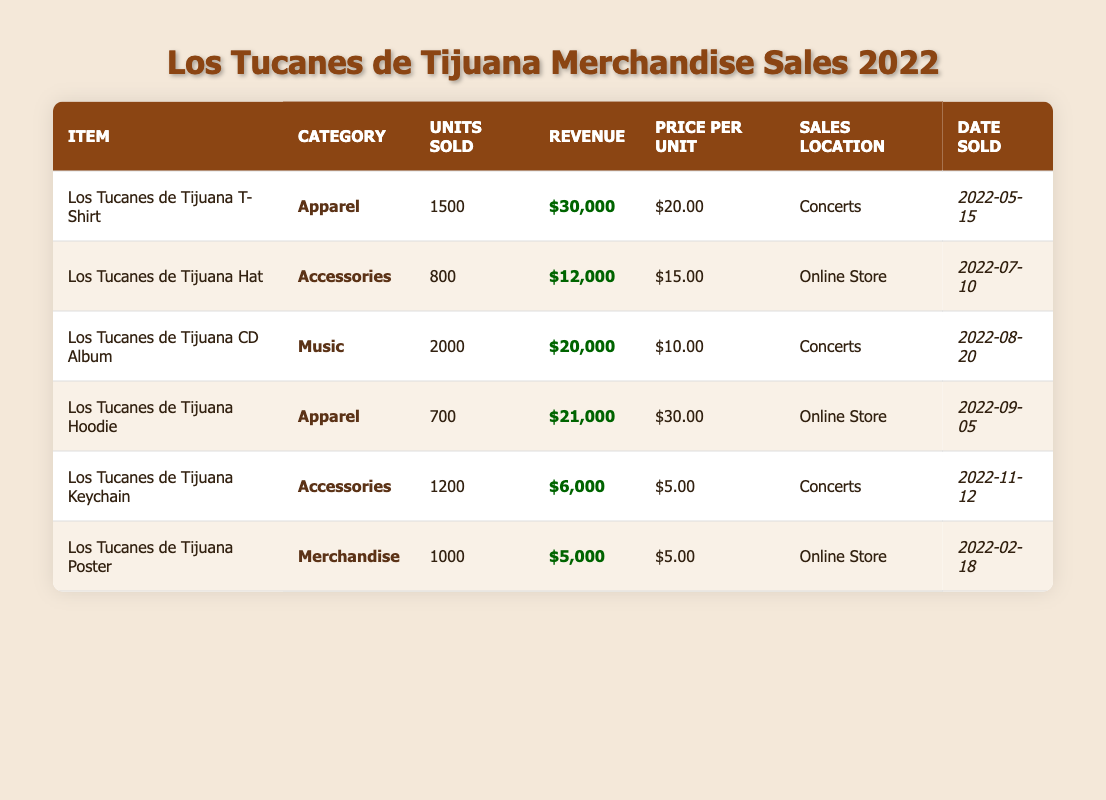What item sold the most units? The item that sold the most units can be found by looking at the "Units Sold" column. Comparing the values, the "Los Tucanes de Tijuana CD Album" has the highest units sold at 2000.
Answer: Los Tucanes de Tijuana CD Album What was the total revenue from merchandise sales? To find the total revenue, we add the revenue for each item: $30,000 + $12,000 + $20,000 + $21,000 + $6,000 + $5,000 = $94,000.
Answer: $94,000 How much revenue did the accessories category generate? The accessories category includes the "Los Tucanes de Tijuana Hat" ($12,000) and "Los Tucanes de Tijuana Keychain" ($6,000). Adding these together gives $12,000 + $6,000 = $18,000.
Answer: $18,000 Did the Los Tucanes de Tijuana generate more revenue from online sales or concert sales? We compare the revenue from online sales ($12,000 from the hat, $21,000 from the hoodie, and $5,000 from the poster) totaling $38,000 to concert sales ($30,000 from the t-shirt, $20,000 from the CD album, and $6,000 from the keychain) totaling $56,000. Since $56,000 is greater than $38,000, concert sales generated more revenue.
Answer: Yes What is the average price per unit for apparel? The apparel items are the "T-Shirt" ($20.00) and "Hoodie" ($30.00). To find the average, we sum the prices ($20.00 + $30.00 = $50.00) and divide by the number of items (2): $50.00 / 2 = $25.00.
Answer: $25.00 Which item had the highest price per unit and what was it? We can look at the "Price per Unit" column to find the item with the highest value. The "Los Tucanes de Tijuana Hoodie" is listed at $30.00, which is higher than the prices of other items.
Answer: Los Tucanes de Tijuana Hoodie, $30.00 What was the sales location for the least sold item? The least sold item is the "Los Tucanes de Tijuana Hoodie," which sold 700 units. Referring to its row, the sales location is "Online Store."
Answer: Online Store How many more units of the CD Album were sold compared to the Keychain? The "CD Album" sold 2000 units and the "Keychain" sold 1200 units. To find the difference, we subtract: 2000 - 1200 = 800.
Answer: 800 What proportion of total units sold came from the T-Shirt? The total units sold can be found by adding all units: 1500 (T-Shirt) + 800 (Hat) + 2000 (CD Album) + 700 (Hoodie) + 1200 (Keychain) + 1000 (Poster) = 6200. The proportion of T-Shirts is 1500 / 6200 = 0.2419, which can be approximately 24.19%.
Answer: 24.19% Did more items sell in the "Concerts" location compared to the "Online Store"? From the table, 4 items were sold at concerts (T-Shirt, CD Album, Keychain) and 3 items were sold at the online store (Hat, Hoodie, Poster). Since 4 is greater than 3, more items sold in concerts.
Answer: Yes 